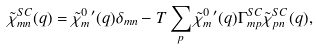Convert formula to latex. <formula><loc_0><loc_0><loc_500><loc_500>\tilde { \chi } _ { m n } ^ { S C } ( { q } ) = \tilde { \chi } _ { m } ^ { 0 } { ^ { \prime } } ( { q } ) \delta _ { m n } - T \sum _ { p } \tilde { \chi } _ { m } ^ { 0 } { ^ { \prime } } ( { q } ) \Gamma _ { m p } ^ { S C } \tilde { \chi } _ { p n } ^ { S C } ( { q } ) ,</formula> 